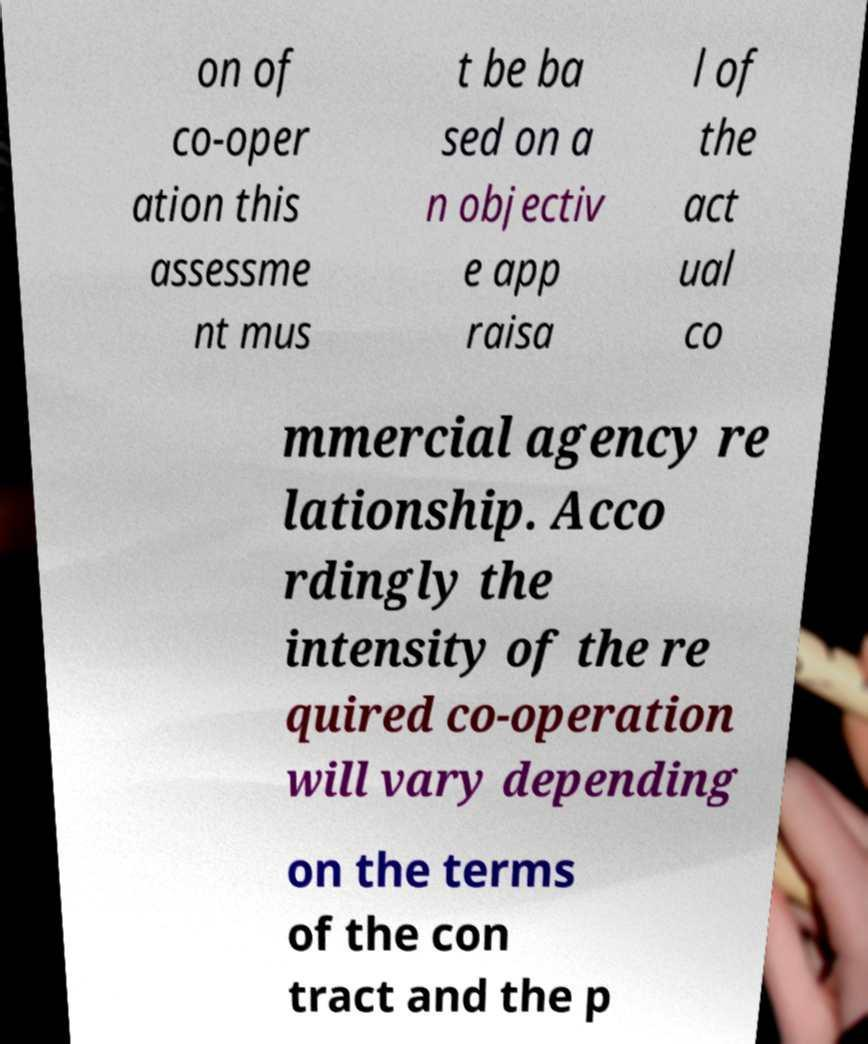What messages or text are displayed in this image? I need them in a readable, typed format. on of co-oper ation this assessme nt mus t be ba sed on a n objectiv e app raisa l of the act ual co mmercial agency re lationship. Acco rdingly the intensity of the re quired co-operation will vary depending on the terms of the con tract and the p 